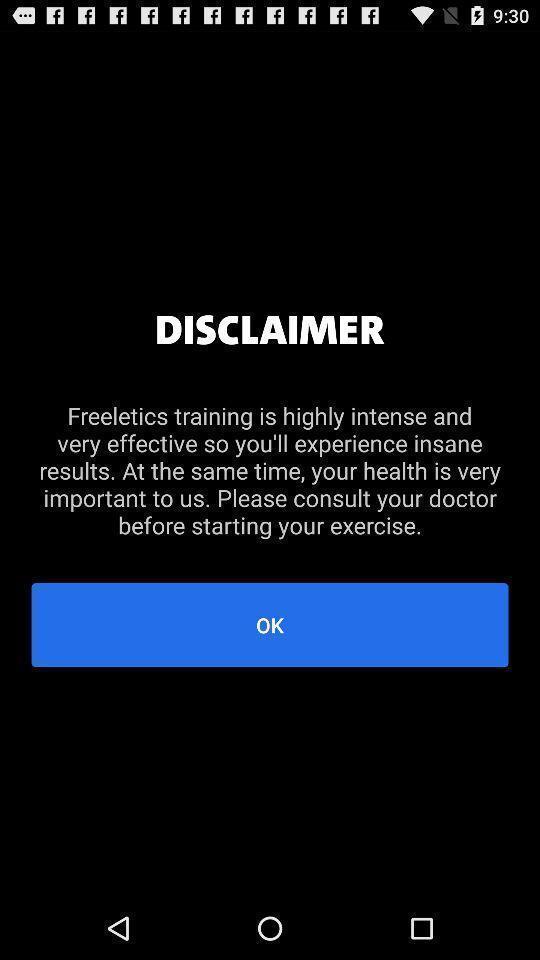What can you discern from this picture? Pop-up displaying about training in workout app. 